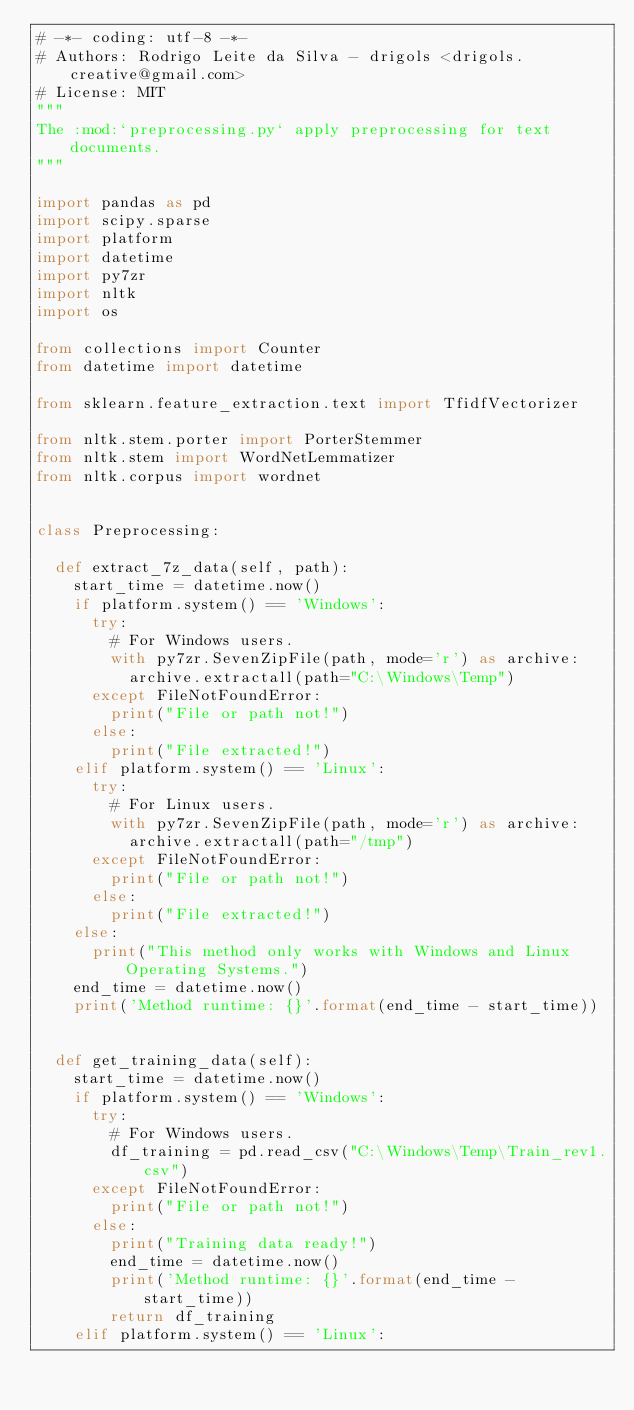<code> <loc_0><loc_0><loc_500><loc_500><_Python_># -*- coding: utf-8 -*-
# Authors: Rodrigo Leite da Silva - drigols <drigols.creative@gmail.com>
# License: MIT
"""
The :mod:`preprocessing.py` apply preprocessing for text documents.
"""

import pandas as pd
import scipy.sparse
import platform
import datetime
import py7zr
import nltk
import os

from collections import Counter
from datetime import datetime

from sklearn.feature_extraction.text import TfidfVectorizer

from nltk.stem.porter import PorterStemmer
from nltk.stem import WordNetLemmatizer
from nltk.corpus import wordnet


class Preprocessing:

  def extract_7z_data(self, path):
    start_time = datetime.now()
    if platform.system() == 'Windows':
      try:
        # For Windows users.
        with py7zr.SevenZipFile(path, mode='r') as archive:
          archive.extractall(path="C:\Windows\Temp")
      except FileNotFoundError:
        print("File or path not!")
      else:
        print("File extracted!")
    elif platform.system() == 'Linux':
      try:
        # For Linux users.
        with py7zr.SevenZipFile(path, mode='r') as archive:
          archive.extractall(path="/tmp")
      except FileNotFoundError:
        print("File or path not!")
      else:
        print("File extracted!")
    else:
      print("This method only works with Windows and Linux Operating Systems.")
    end_time = datetime.now()
    print('Method runtime: {}'.format(end_time - start_time))


  def get_training_data(self):
    start_time = datetime.now()
    if platform.system() == 'Windows':
      try:
        # For Windows users.
        df_training = pd.read_csv("C:\Windows\Temp\Train_rev1.csv")
      except FileNotFoundError:
        print("File or path not!")
      else:
        print("Training data ready!")
        end_time = datetime.now()
        print('Method runtime: {}'.format(end_time - start_time))
        return df_training
    elif platform.system() == 'Linux':</code> 